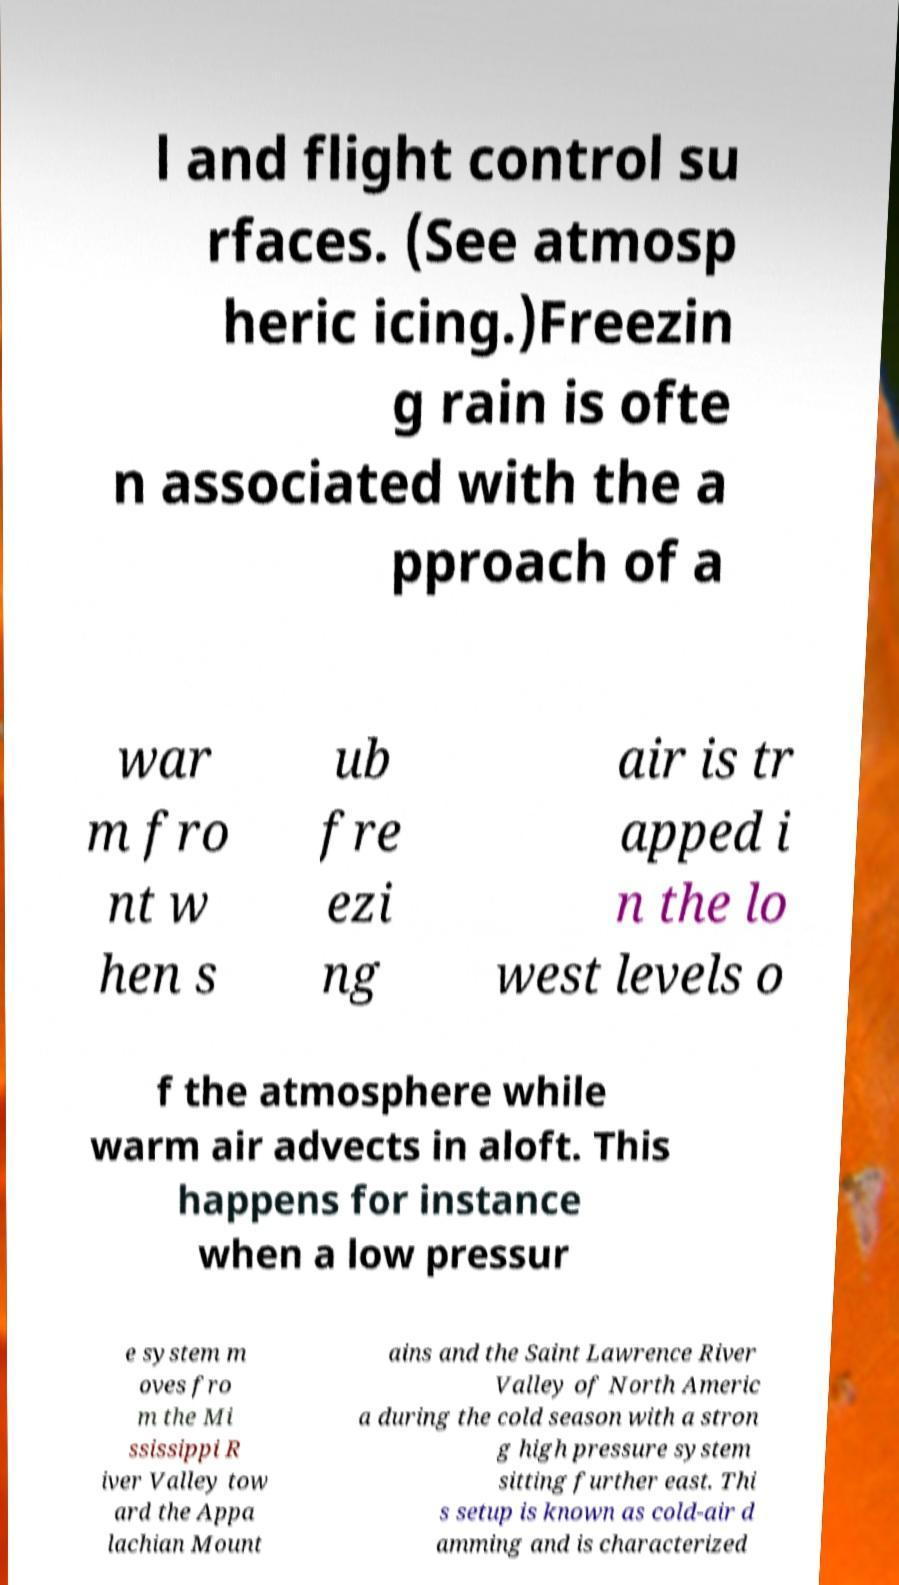What messages or text are displayed in this image? I need them in a readable, typed format. l and flight control su rfaces. (See atmosp heric icing.)Freezin g rain is ofte n associated with the a pproach of a war m fro nt w hen s ub fre ezi ng air is tr apped i n the lo west levels o f the atmosphere while warm air advects in aloft. This happens for instance when a low pressur e system m oves fro m the Mi ssissippi R iver Valley tow ard the Appa lachian Mount ains and the Saint Lawrence River Valley of North Americ a during the cold season with a stron g high pressure system sitting further east. Thi s setup is known as cold-air d amming and is characterized 